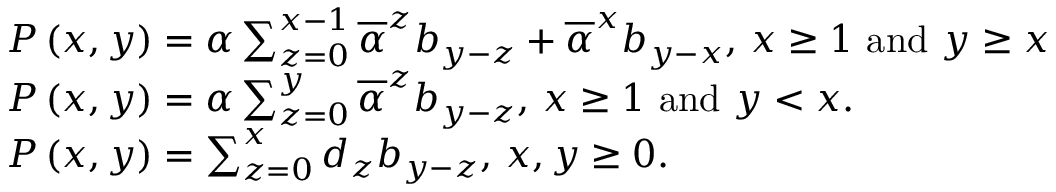Convert formula to latex. <formula><loc_0><loc_0><loc_500><loc_500>\begin{array} { l } { P \left ( x , y \right ) = \alpha \sum _ { z = 0 } ^ { x - 1 } \overline { \alpha } ^ { z } b _ { y - z } + \overline { \alpha } ^ { x } b _ { y - x } , x \geq 1 a n d y \geq x } \\ { P \left ( x , y \right ) = \alpha \sum _ { z = 0 } ^ { y } \overline { \alpha } ^ { z } b _ { y - z } , x \geq 1 a n d y < x . } \\ { P \left ( x , y \right ) = \sum _ { z = 0 } ^ { x } d _ { z } b _ { y - z } , x , y \geq 0 . } \end{array}</formula> 